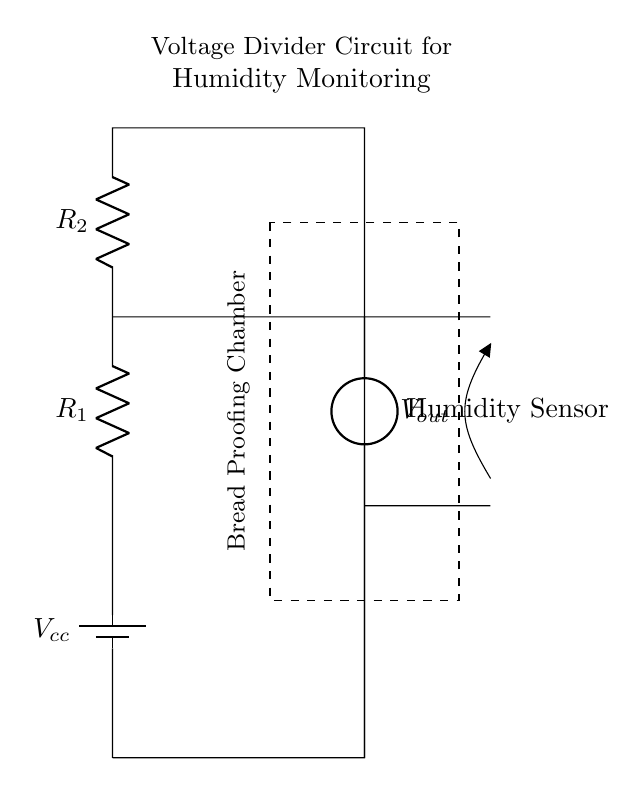What is the purpose of this circuit? The circuit is designed to monitor humidity levels in a bread proofing chamber, utilizing a humidity sensor to measure the moisture content in the air.
Answer: Humidity monitoring What is connected to the output of this circuit? The output of the circuit connects to the humidity sensor, which provides humidity readings based on the voltage divider configuration.
Answer: Humidity sensor What do R1 and R2 represent in this circuit? R1 and R2 represent the resistors in the voltage divider, which determine the fraction of the input voltage that appears at the output.
Answer: Resistors What is the function of the voltage divider in this circuit? The voltage divider reduces the input voltage from the power supply to a lower output voltage, which can be read by the humidity sensor, allowing it to function correctly.
Answer: Voltage reduction How is the bread proofing chamber indicated in the circuit? The bread proofing chamber is denoted by a dashed rectangle labeled with that text, showing the area where the humidity monitoring takes place.
Answer: Dashed rectangle What would happen if R1 or R2 is changed? Changing R1 or R2 will alter the output voltage, affecting the readings from the humidity sensor and potentially causing inaccurate moisture level measurements.
Answer: Output voltage affects 